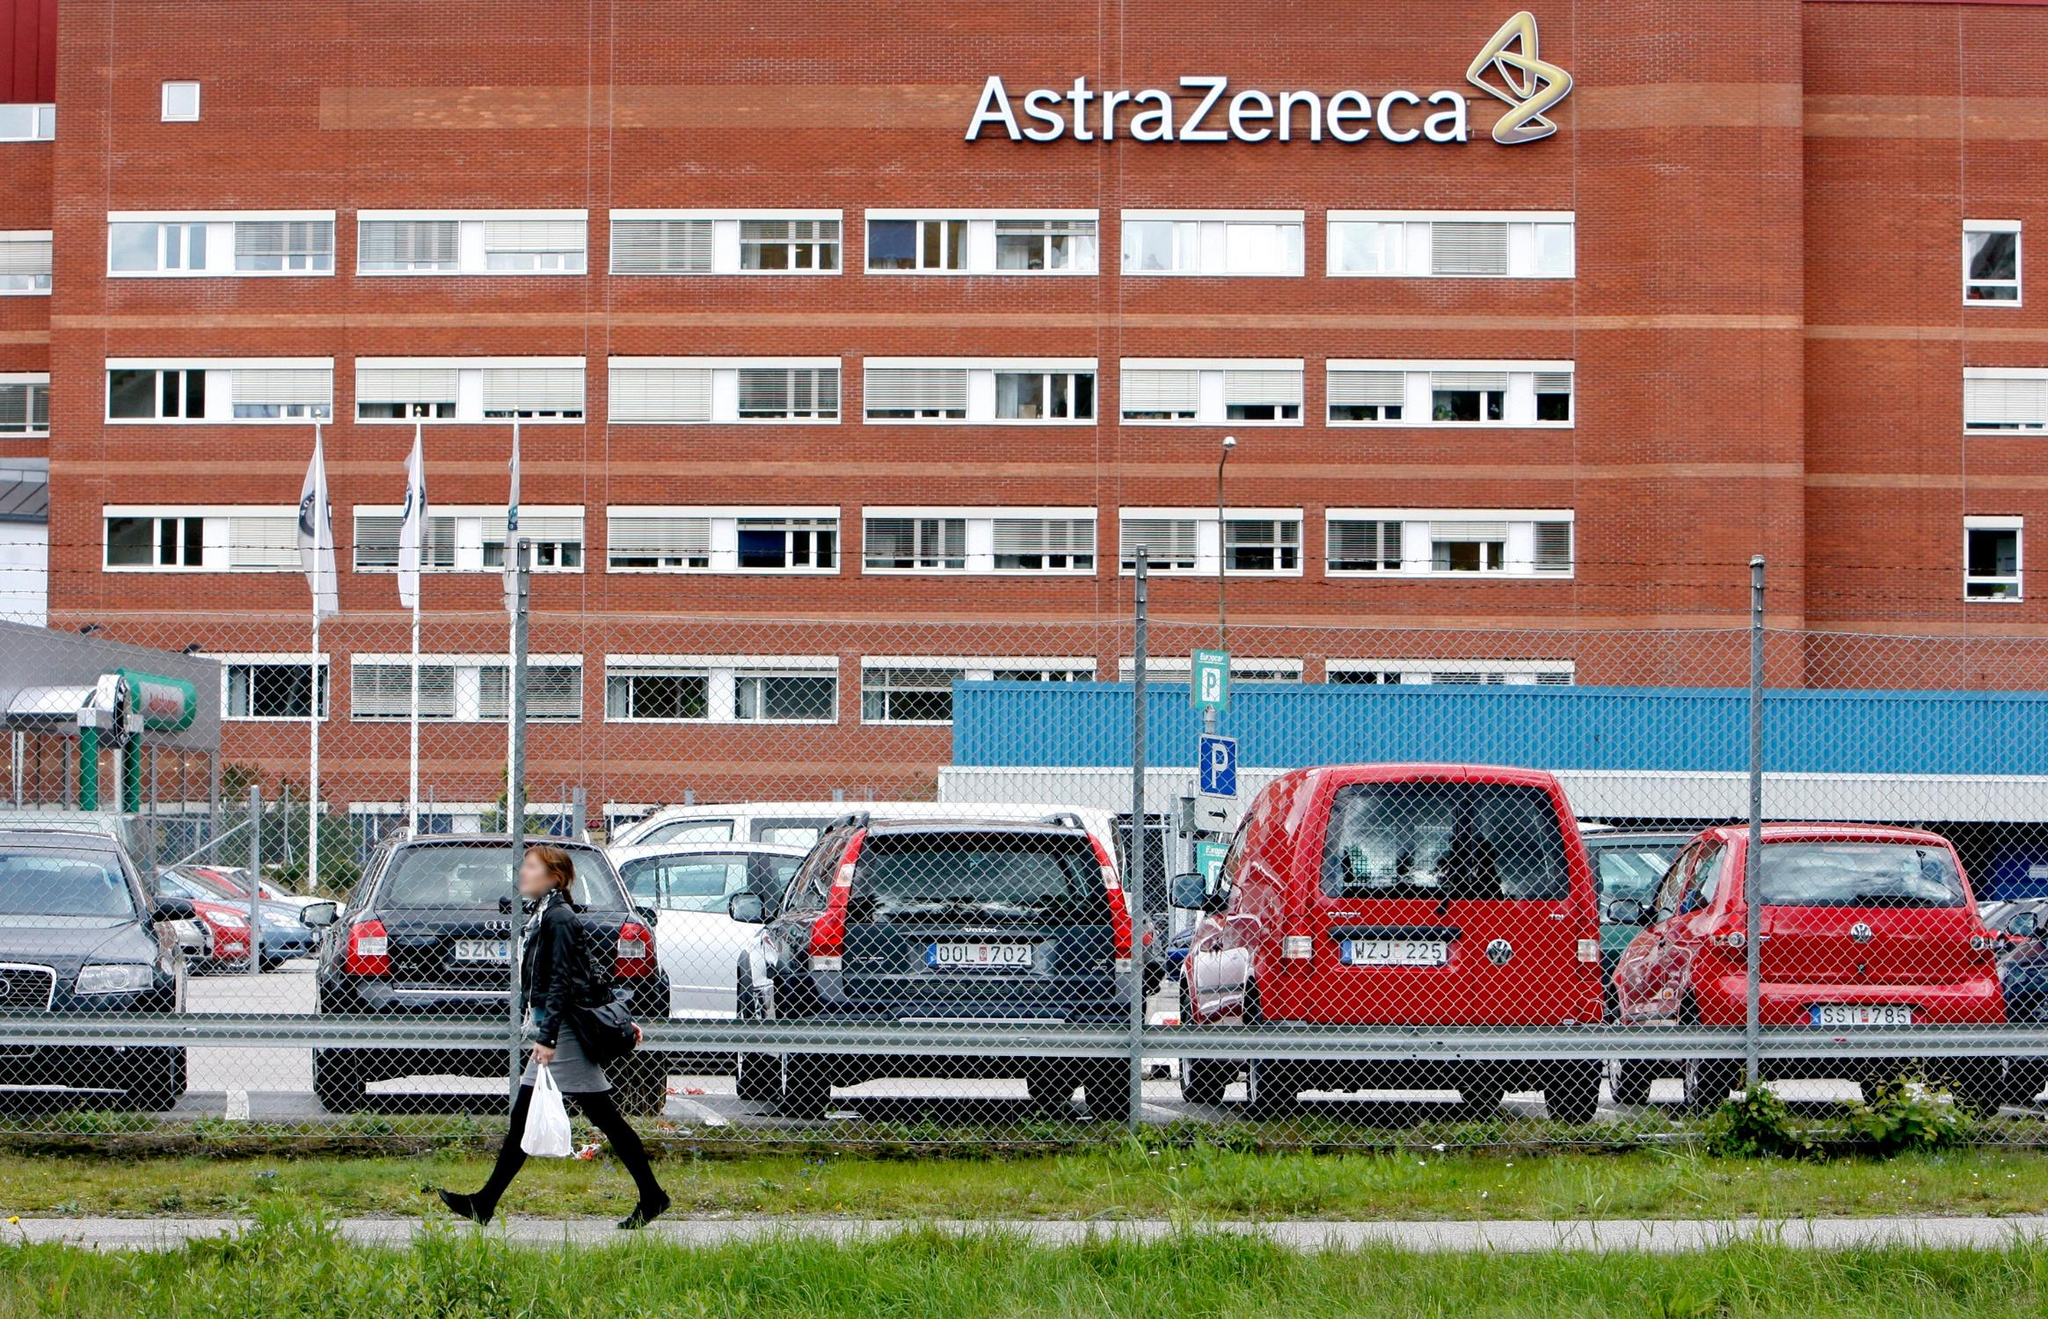Describe more about the architecture and any unique design features of the AstraZeneca building. The AstraZeneca building’s architecture is a remarkable example of functional design infused with a sense of robust solidity. The red brick facade is both aesthetically pleasing and enduring, providing a warm yet professional appearance. Large, evenly spaced windows punctuate the brickwork, allowing ample natural light to penetrate the interior while maintaining an orderly, rhythmic exterior view. The building's rectangular shape and its grid-like symmetry highlight a utilitarian yet sophisticated design philosophy. The company's logo, prominently displayed on the top right corner, stands out against the brick background, symbolizing both pride in the brand and a beacon of its global presence. 